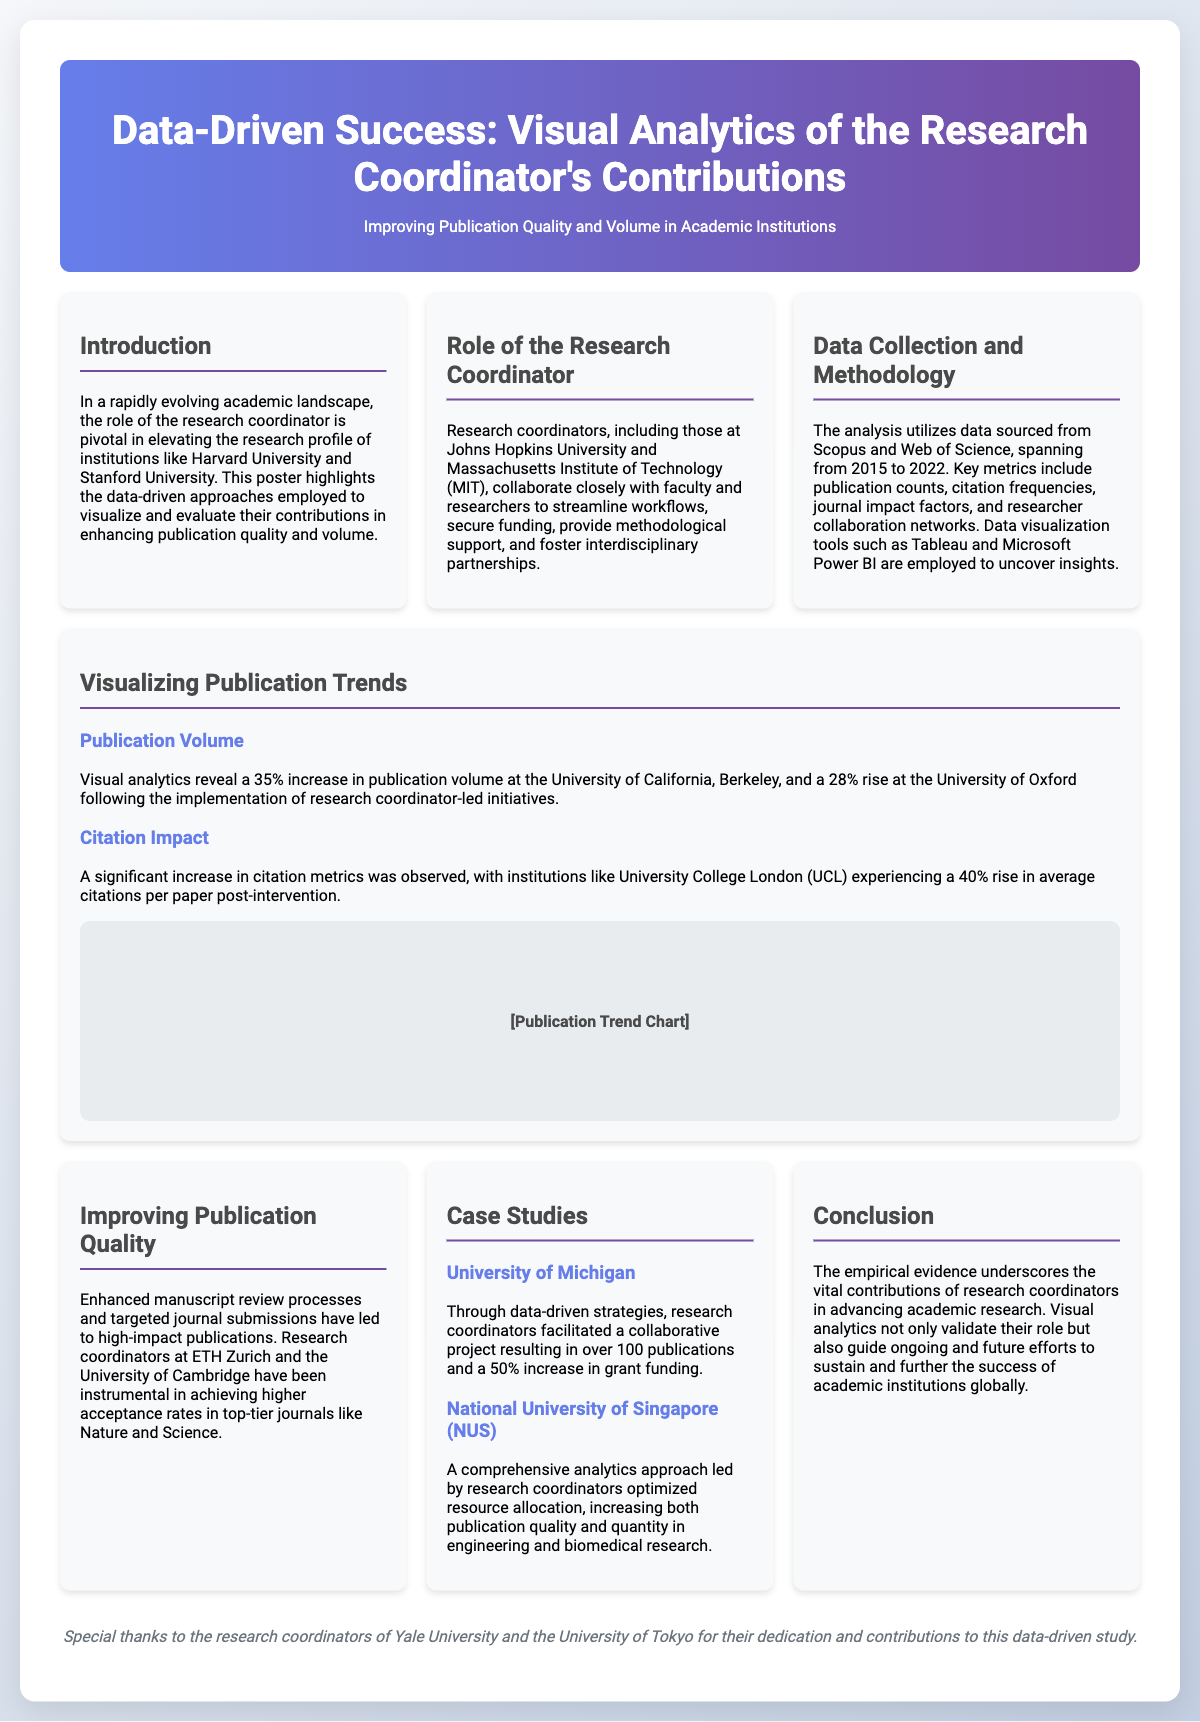What is the primary focus of this poster? The poster highlights the data-driven approaches employed to visualize and evaluate the contributions of research coordinators in enhancing publication quality and volume.
Answer: Publication quality and volume What percentage increase in publication volume was reported for the University of California, Berkeley? The visual analytics reveal a 35% increase in publication volume at the University of California, Berkeley.
Answer: 35% Which tools were used for data visualization in this analysis? Data visualization tools such as Tableau and Microsoft Power BI are employed to uncover insights.
Answer: Tableau and Microsoft Power BI What was the impact of research coordinator-led initiatives on citation metrics at University College London? A significant increase in citation metrics was observed, with UCL experiencing a 40% rise in average citations per paper post-intervention.
Answer: 40% Which journal is mentioned as a target for high-impact publications? The research coordinators have been instrumental in achieving higher acceptance rates in top-tier journals like Nature and Science.
Answer: Nature and Science What is the total number of publications resulting from the University of Michigan's collaborative project? Through data-driven strategies, research coordinators facilitated a collaborative project resulting in over 100 publications.
Answer: Over 100 Which two universities are specifically acknowledged for their research coordinators' contributions? Special thanks are given to the research coordinators of Yale University and the University of Tokyo.
Answer: Yale University and University of Tokyo What is the duration of the data analysis mentioned in the document? The analysis utilizes data sourced from Scopus and Web of Science, spanning from 2015 to 2022.
Answer: 2015 to 2022 